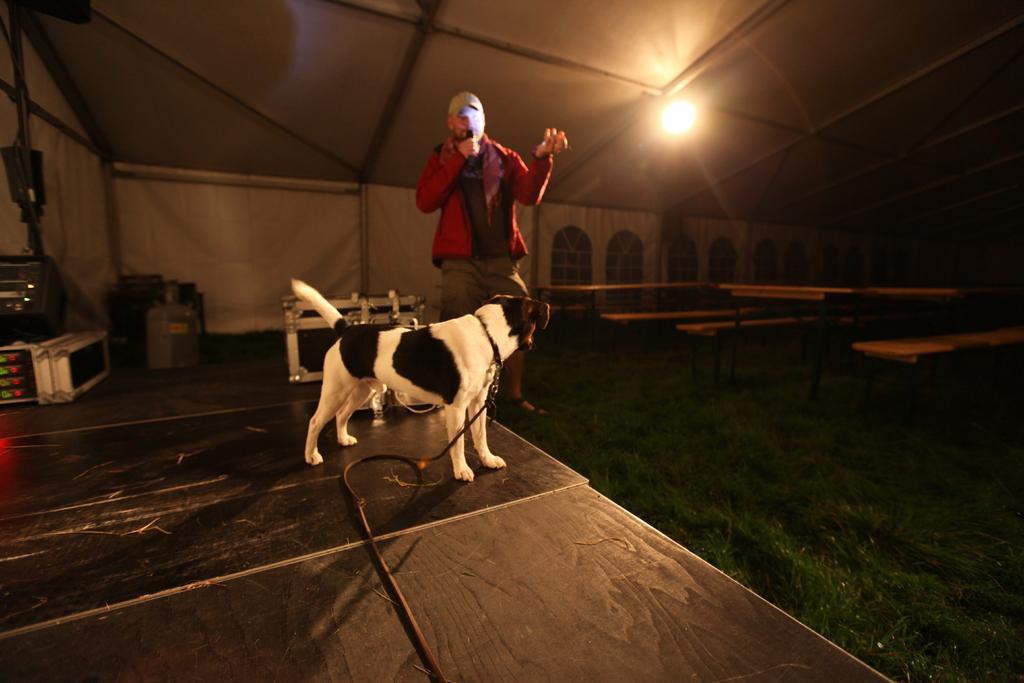How would you summarize this image in a sentence or two? As we can see in the image there is a wall, windows, light, dog and a person wearing red color shirt, cap and holding a mic. 